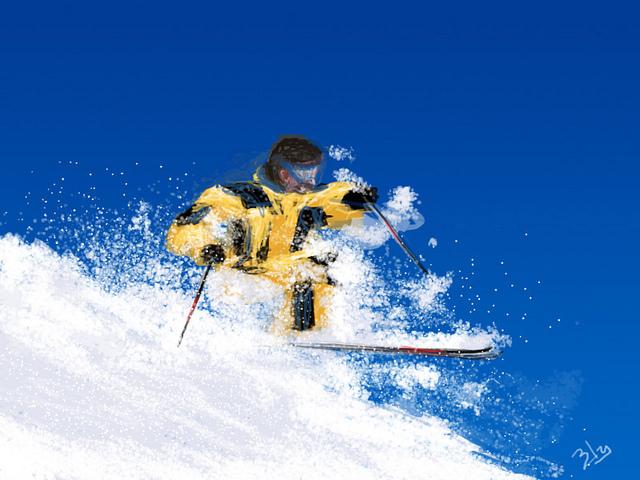What color is the sky?
Concise answer only. Blue. What color is his goggles?
Concise answer only. Blue. Is it a sunny day?
Answer briefly. Yes. 